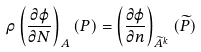Convert formula to latex. <formula><loc_0><loc_0><loc_500><loc_500>\rho \left ( \frac { \partial \varphi } { \partial N } \right ) _ { A } ( P ) = \left ( \frac { \partial \varphi } { \partial n } \right ) _ { \widetilde { A } ^ { k } } ( \widetilde { P } )</formula> 